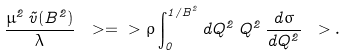Convert formula to latex. <formula><loc_0><loc_0><loc_500><loc_500>\frac { \mu ^ { 2 } \, \tilde { v } ( B ^ { 2 } ) } { \lambda } \ > = \ > \rho \int _ { 0 } ^ { 1 / B ^ { 2 } } d Q ^ { 2 } \, Q ^ { 2 } \, \frac { d \sigma } { d Q ^ { 2 } } \ > .</formula> 